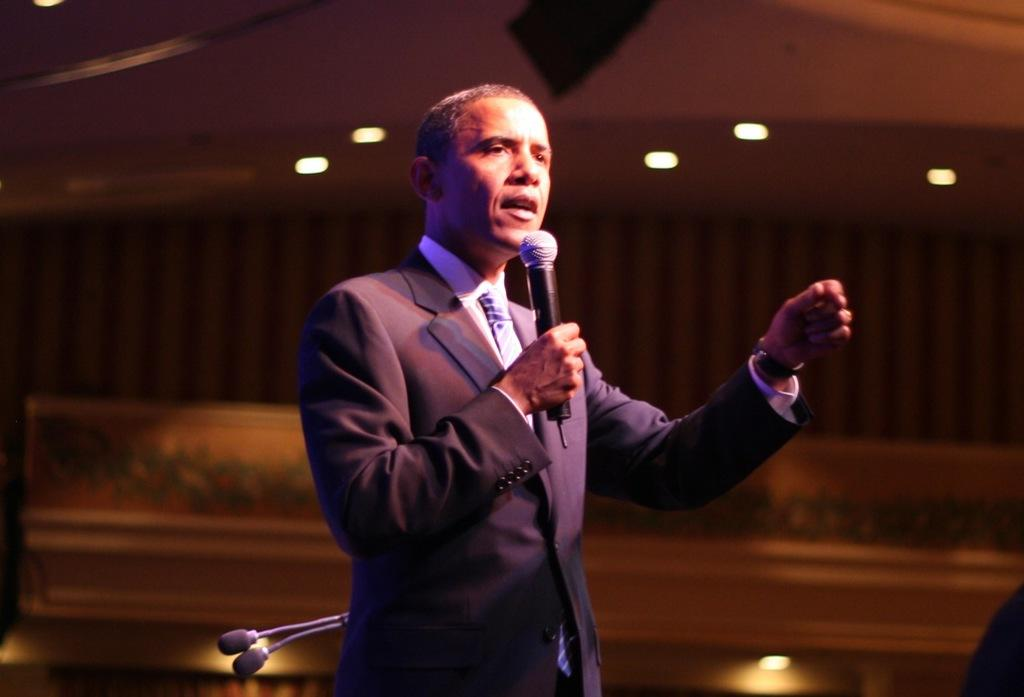Who is in the image? There is a person in the image. What is the person holding? The person is holding a microphone. What is the person doing with the microphone? The person is speaking. Are there any other microphones visible in the image? Yes, there are additional microphones visible in the background. What can be seen in the image that provides illumination? There are lights present in the image. What type of lamp is being used to whip the person in the image? There is no lamp or whip present in the image. The person is holding a microphone and speaking. 